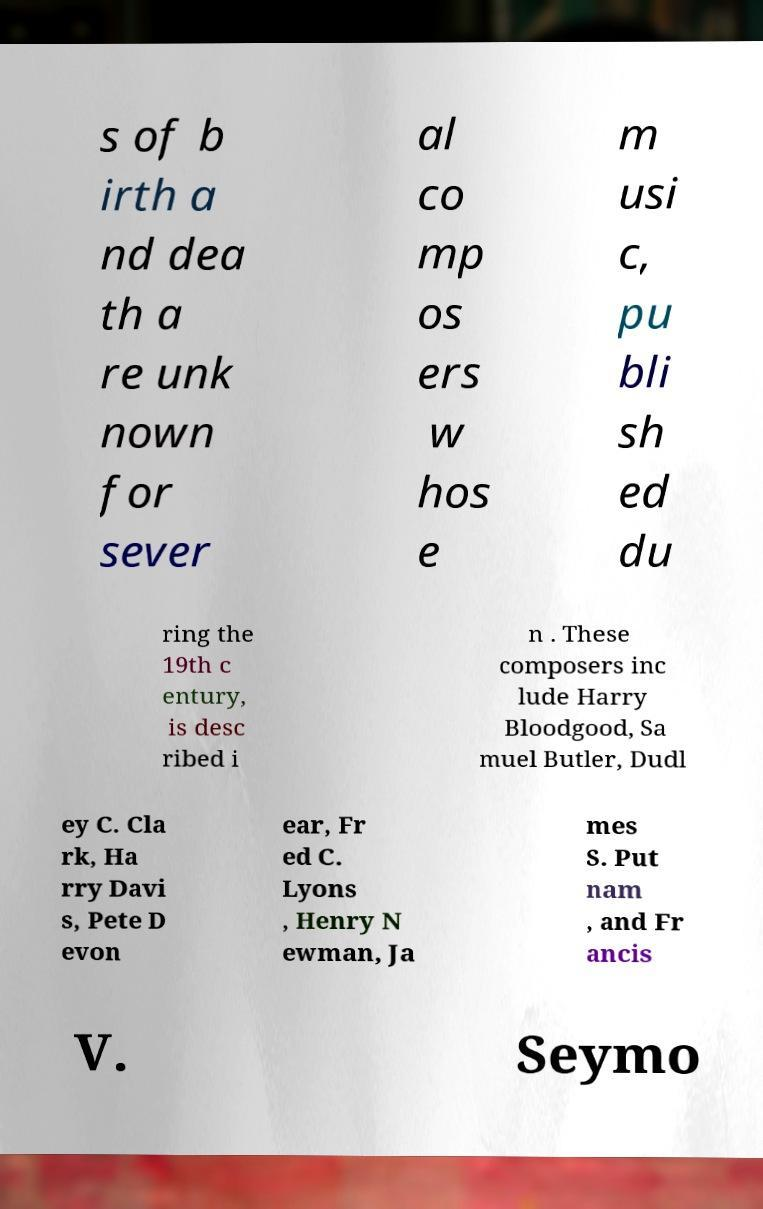What messages or text are displayed in this image? I need them in a readable, typed format. s of b irth a nd dea th a re unk nown for sever al co mp os ers w hos e m usi c, pu bli sh ed du ring the 19th c entury, is desc ribed i n . These composers inc lude Harry Bloodgood, Sa muel Butler, Dudl ey C. Cla rk, Ha rry Davi s, Pete D evon ear, Fr ed C. Lyons , Henry N ewman, Ja mes S. Put nam , and Fr ancis V. Seymo 